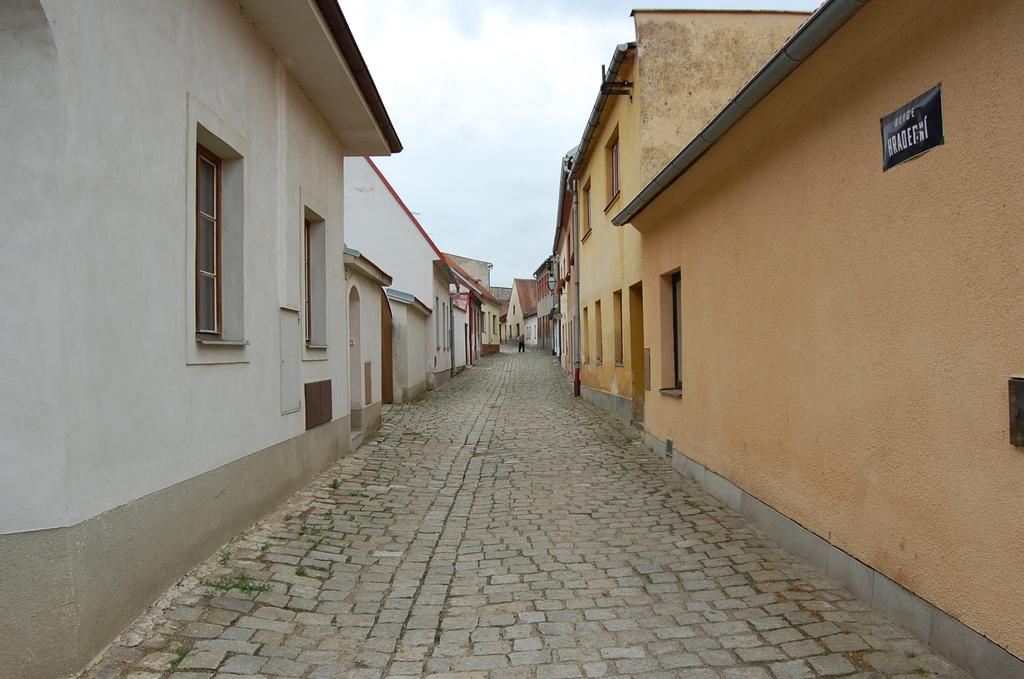What type of structures can be seen in the image? There are buildings in the image. What feature is visible on the buildings? There are windows visible in the image. What is hanging on a wall in the image? There is a poster on a wall in the image. How would you describe the weather in the image? The sky is cloudy in the image. What type of secretary can be seen working in the image? There is no secretary present in the image; it features buildings, windows, a poster, and a cloudy sky. What type of flight is taking off in the image? There is no flight present in the image; it only shows buildings, windows, a poster, and a cloudy sky. 